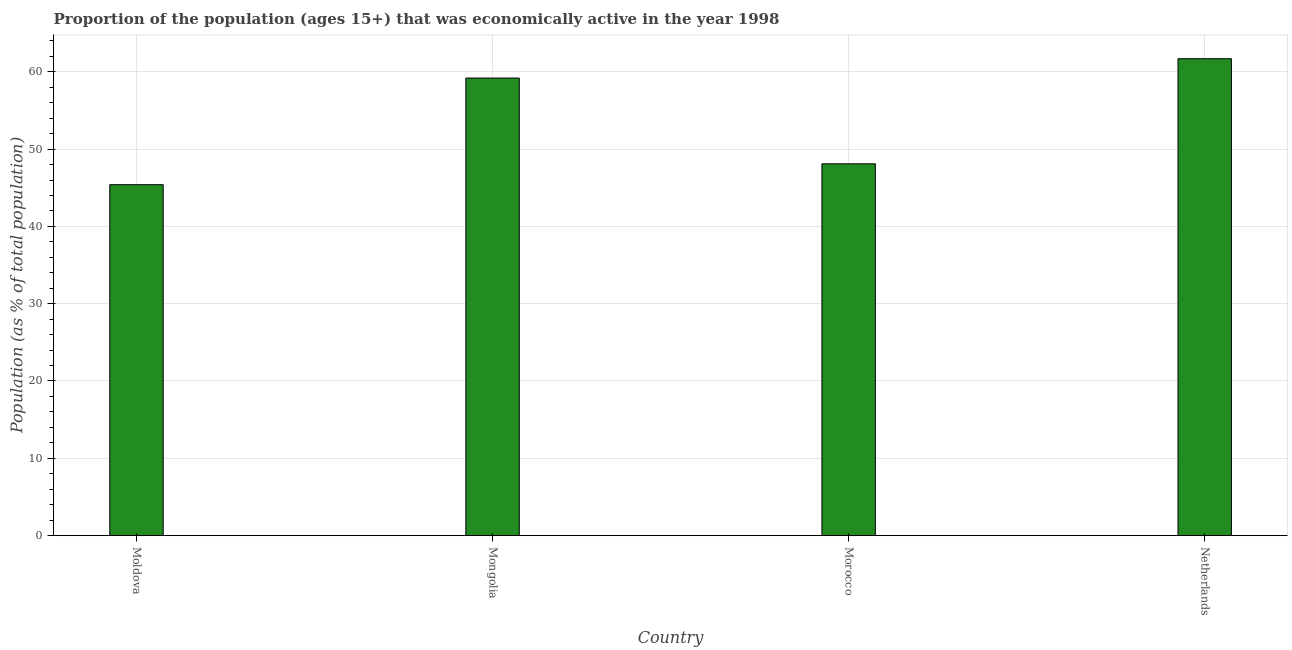Does the graph contain grids?
Provide a succinct answer. Yes. What is the title of the graph?
Your answer should be compact. Proportion of the population (ages 15+) that was economically active in the year 1998. What is the label or title of the X-axis?
Provide a succinct answer. Country. What is the label or title of the Y-axis?
Offer a terse response. Population (as % of total population). What is the percentage of economically active population in Netherlands?
Give a very brief answer. 61.7. Across all countries, what is the maximum percentage of economically active population?
Give a very brief answer. 61.7. Across all countries, what is the minimum percentage of economically active population?
Make the answer very short. 45.4. In which country was the percentage of economically active population minimum?
Your answer should be compact. Moldova. What is the sum of the percentage of economically active population?
Your answer should be very brief. 214.4. What is the average percentage of economically active population per country?
Make the answer very short. 53.6. What is the median percentage of economically active population?
Offer a terse response. 53.65. In how many countries, is the percentage of economically active population greater than 40 %?
Your answer should be compact. 4. What is the ratio of the percentage of economically active population in Moldova to that in Morocco?
Offer a terse response. 0.94. In how many countries, is the percentage of economically active population greater than the average percentage of economically active population taken over all countries?
Your answer should be very brief. 2. How many bars are there?
Your response must be concise. 4. Are all the bars in the graph horizontal?
Make the answer very short. No. Are the values on the major ticks of Y-axis written in scientific E-notation?
Make the answer very short. No. What is the Population (as % of total population) in Moldova?
Give a very brief answer. 45.4. What is the Population (as % of total population) in Mongolia?
Provide a short and direct response. 59.2. What is the Population (as % of total population) in Morocco?
Offer a terse response. 48.1. What is the Population (as % of total population) in Netherlands?
Keep it short and to the point. 61.7. What is the difference between the Population (as % of total population) in Moldova and Netherlands?
Offer a terse response. -16.3. What is the difference between the Population (as % of total population) in Morocco and Netherlands?
Your answer should be very brief. -13.6. What is the ratio of the Population (as % of total population) in Moldova to that in Mongolia?
Offer a very short reply. 0.77. What is the ratio of the Population (as % of total population) in Moldova to that in Morocco?
Ensure brevity in your answer.  0.94. What is the ratio of the Population (as % of total population) in Moldova to that in Netherlands?
Provide a succinct answer. 0.74. What is the ratio of the Population (as % of total population) in Mongolia to that in Morocco?
Keep it short and to the point. 1.23. What is the ratio of the Population (as % of total population) in Morocco to that in Netherlands?
Provide a succinct answer. 0.78. 